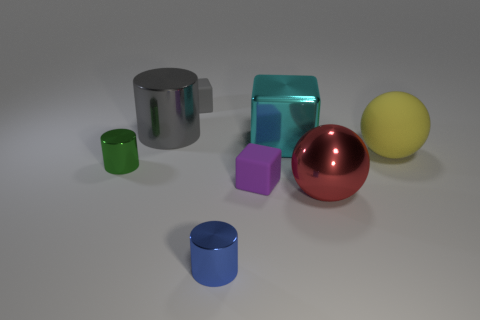What number of other objects are there of the same material as the blue cylinder?
Make the answer very short. 4. Are there fewer tiny metallic objects than metallic objects?
Keep it short and to the point. Yes. Are the large block and the cylinder on the right side of the large gray object made of the same material?
Give a very brief answer. Yes. There is a tiny shiny thing left of the blue shiny thing; what shape is it?
Keep it short and to the point. Cylinder. Is there anything else that has the same color as the large shiny cylinder?
Keep it short and to the point. Yes. Is the number of cyan cubes that are behind the cyan thing less than the number of small green shiny cylinders?
Your answer should be very brief. Yes. What number of metal things have the same size as the rubber sphere?
Your response must be concise. 3. What is the shape of the rubber object that is the same color as the large shiny cylinder?
Your response must be concise. Cube. What is the shape of the tiny thing on the right side of the object in front of the large metallic thing that is in front of the big yellow rubber object?
Provide a short and direct response. Cube. What color is the tiny cube in front of the big rubber thing?
Keep it short and to the point. Purple. 